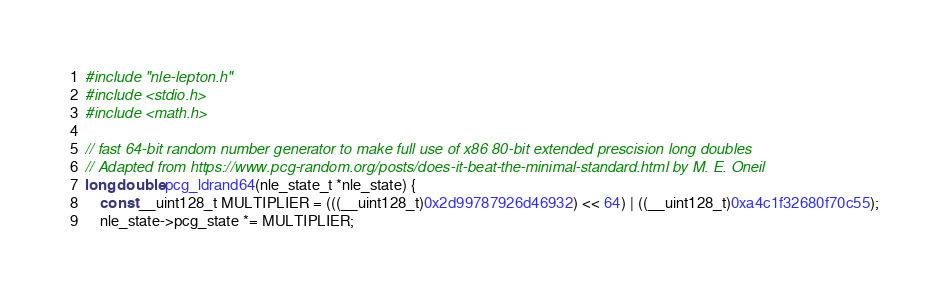<code> <loc_0><loc_0><loc_500><loc_500><_C_>#include "nle-lepton.h"
#include <stdio.h>
#include <math.h>

// fast 64-bit random number generator to make full use of x86 80-bit extended prescision long doubles
// Adapted from https://www.pcg-random.org/posts/does-it-beat-the-minimal-standard.html by M. E. Oneil
long double pcg_ldrand64(nle_state_t *nle_state) {
    const __uint128_t MULTIPLIER = (((__uint128_t)0x2d99787926d46932) << 64) | ((__uint128_t)0xa4c1f32680f70c55);
    nle_state->pcg_state *= MULTIPLIER;</code> 